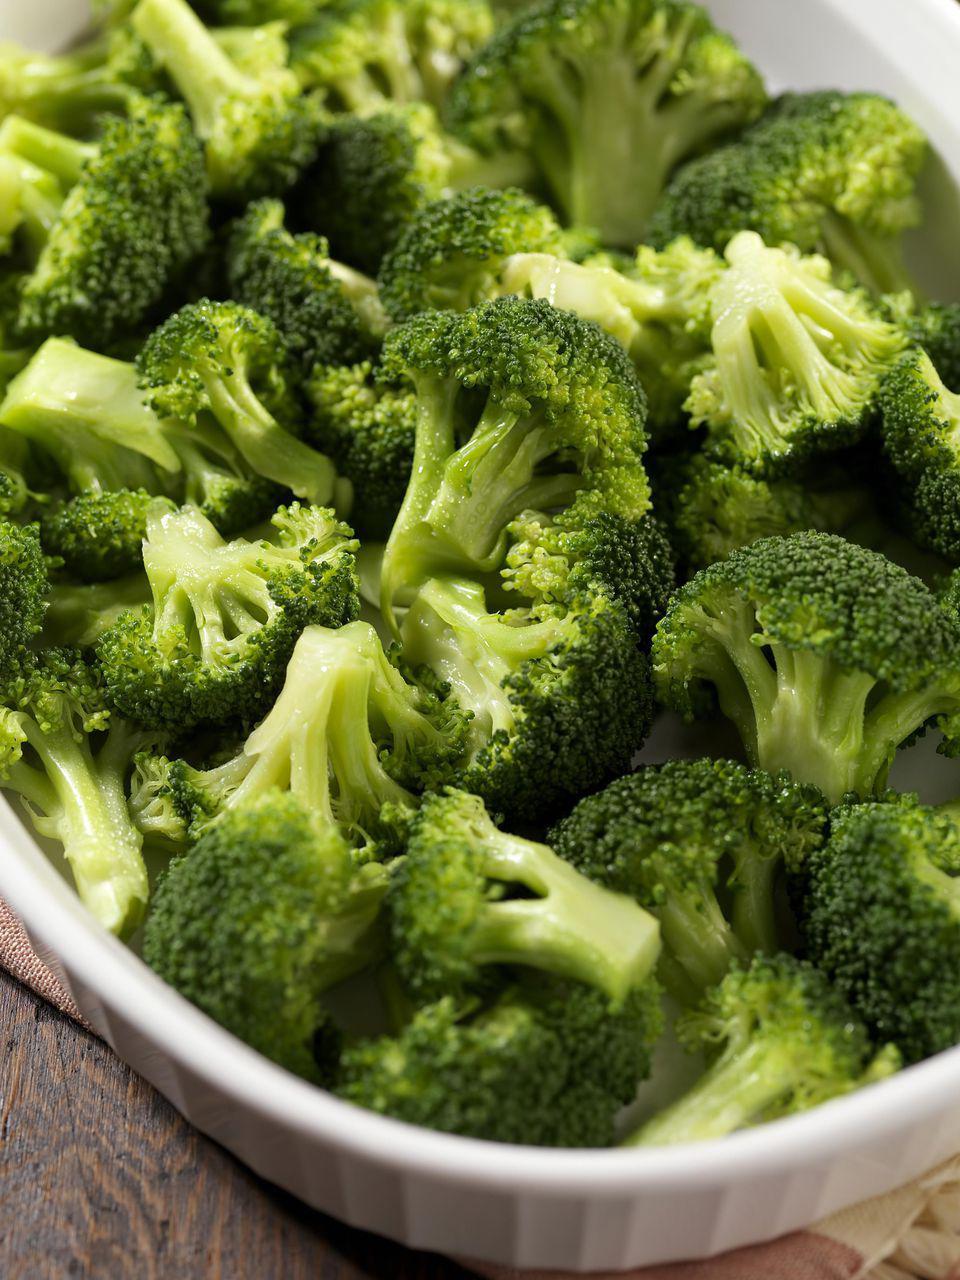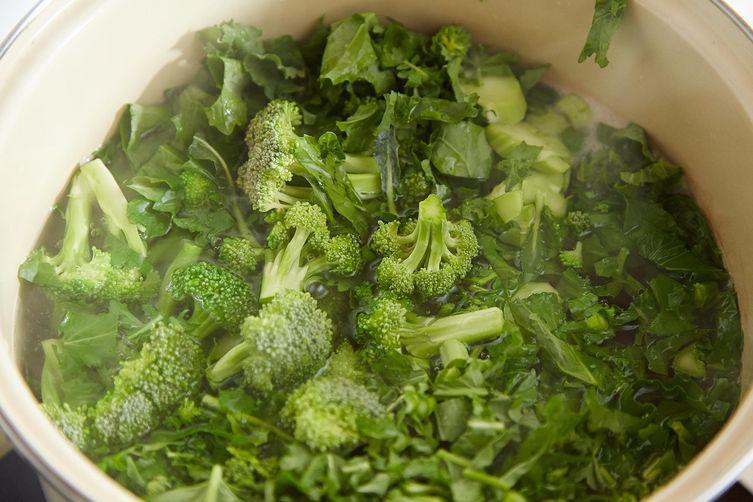The first image is the image on the left, the second image is the image on the right. Considering the images on both sides, is "Right image shows broccoli in a deep container with water." valid? Answer yes or no. Yes. The first image is the image on the left, the second image is the image on the right. Evaluate the accuracy of this statement regarding the images: "One photo features a container made of metal.". Is it true? Answer yes or no. No. 